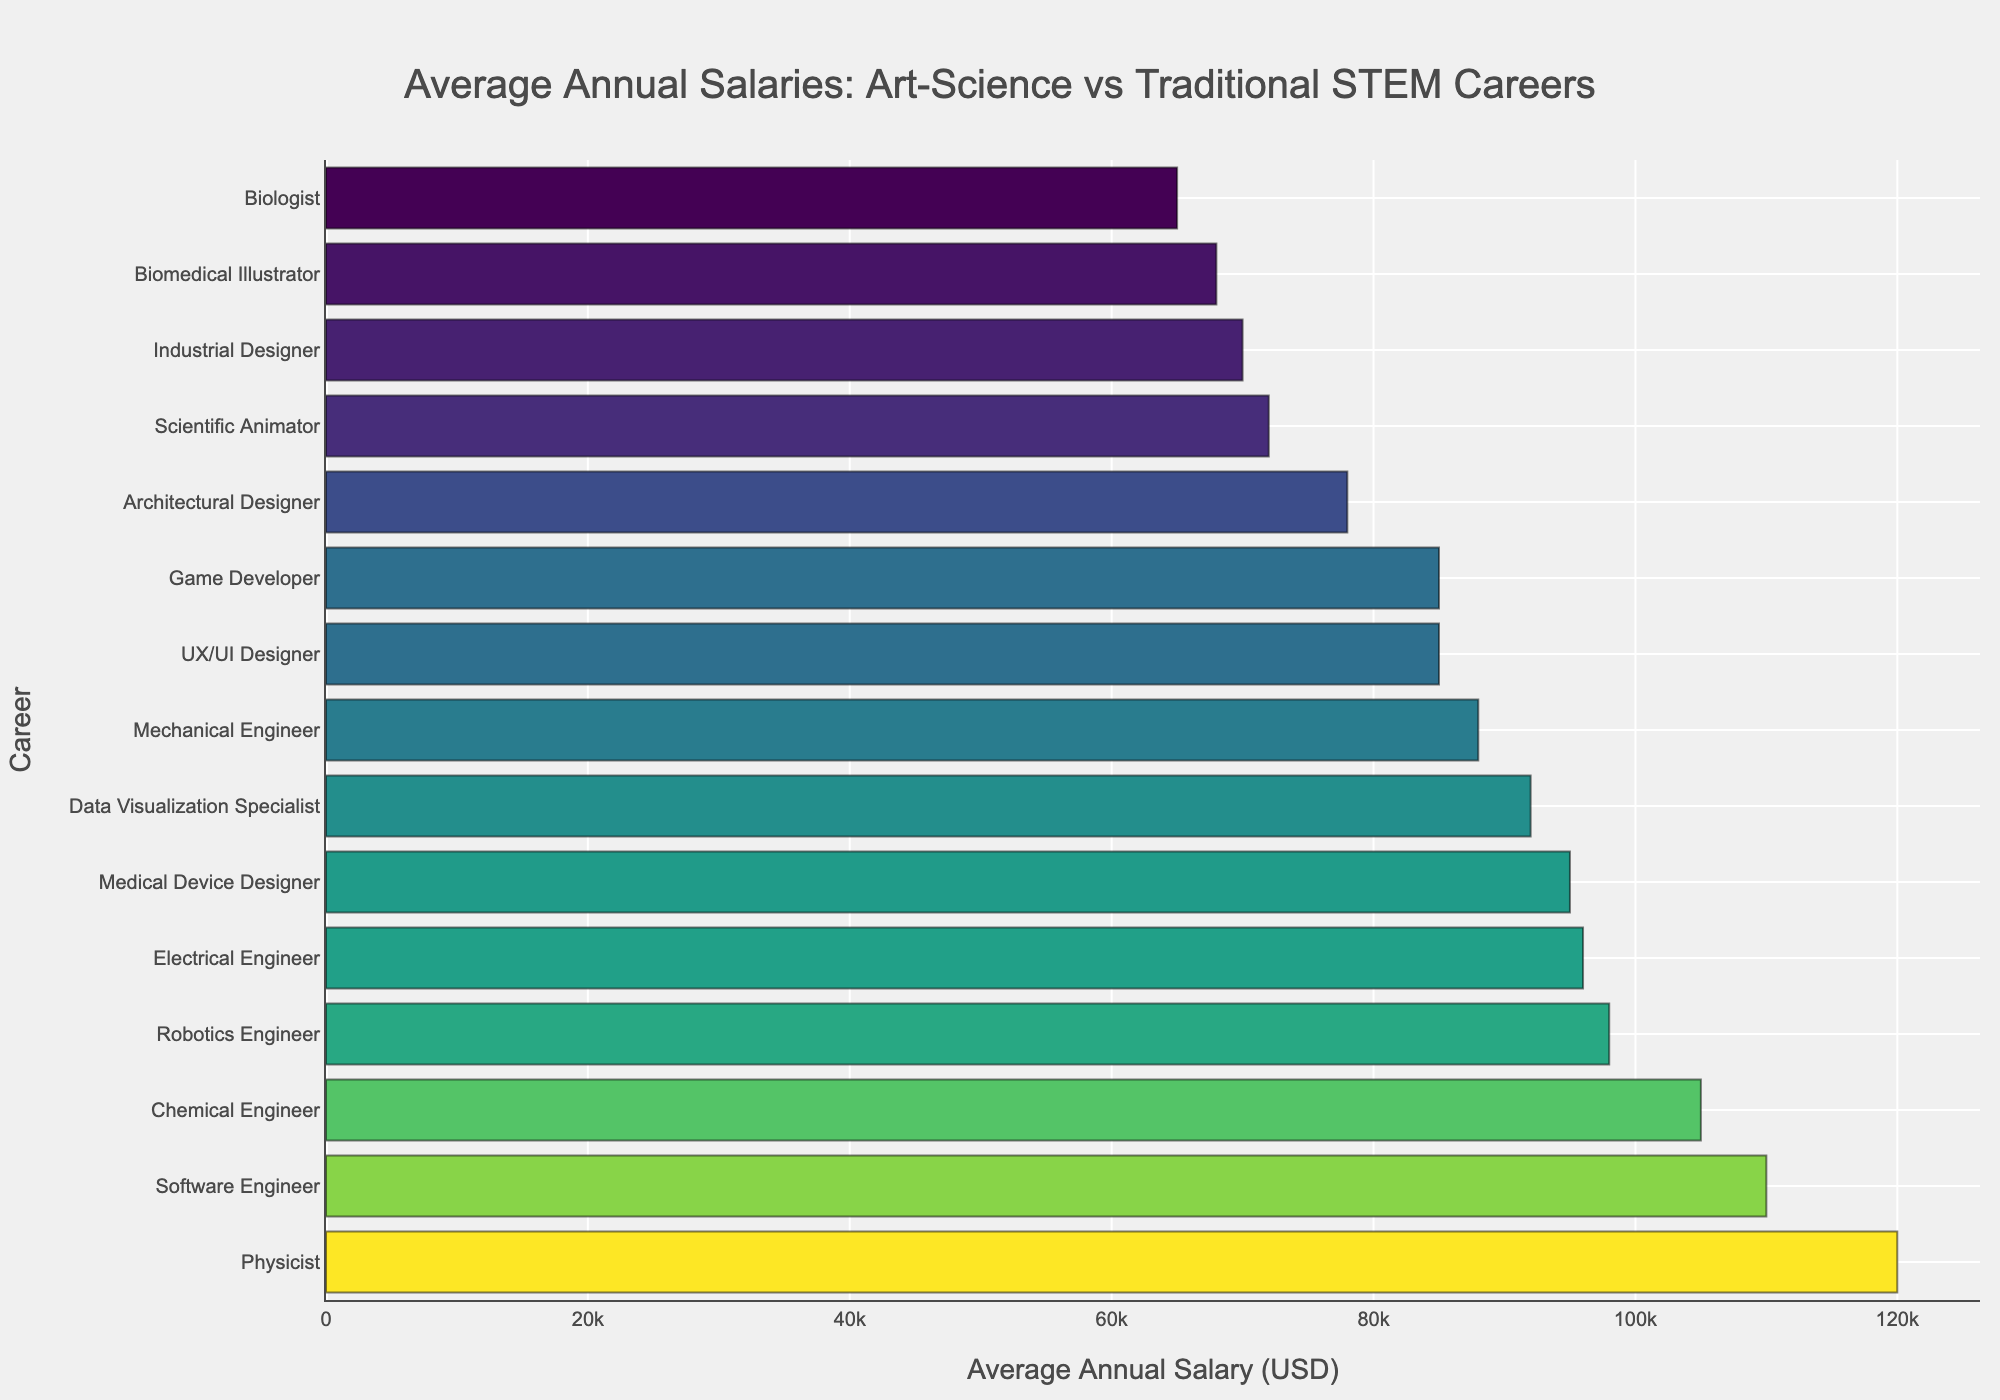Which career has the highest average annual salary? By inspecting the bar chart, the career with the longest bar represents the highest salary. The label next to the longest bar is "Physicist" with a salary of $120,000.
Answer: Physicist Which career has the lowest average annual salary? By looking at the shortest bar in the chart, the career "Biologist" has the shortest bar indicating the lowest average annual salary, which is $65,000.
Answer: Biologist Is the average annual salary of a Biomedical Illustrator higher or lower than a Data Visualization Specialist? By comparing the lengths of the bars for "Biomedical Illustrator" and "Data Visualization Specialist," we can see that the bar for "Data Visualization Specialist" is longer. Therefore, the average salary of a Data Visualization Specialist ($92,000) is higher than that of a Biomedical Illustrator ($68,000).
Answer: Lower How much more does a Software Engineer make compared to an Architect? The bar for "Software Engineer" represents an average annual salary of $110,000, while the bar for "Architectural Designer" represents $78,000. Subtracting these values, $110,000 - $78,000, we find that a Software Engineer makes $32,000 more.
Answer: $32,000 What is the combined average annual salary of a UX/UI Designer and a Game Developer? The bars for "UX/UI Designer" and "Game Developer" show salaries of $85,000 each. Adding these two amounts together, $85,000 + $85,000, gives us a combined salary of $170,000.
Answer: $170,000 Which traditional STEM career has the highest average annual salary? Among traditional STEM careers listed (Software Engineer, Mechanical Engineer, Electrical Engineer, Chemical Engineer, Biologist, Physicist), we observe that the "Physicist" has the longest bar with a salary of $120,000.
Answer: Physicist Do Industrial Designers earn more or less than Biomedical Illustrators and by how much? The bars for "Industrial Designer" and "Biomedical Illustrator" show salaries of $70,000 and $68,000, respectively. Subtracting the latter from the former, $70,000 - $68,000, we see that Industrial Designers earn $2,000 more.
Answer: $2,000 more Among art-science careers, which one has the highest average annual salary? Inspecting the bars related to art-science careers (Biomedical Illustrator, Scientific Animator, UX/UI Designer, Data Visualization Specialist, Medical Device Designer, Architectural Designer, Industrial Designer, Game Developer), the "Medical Device Designer" has the longest bar indicating the highest salary at $95,000.
Answer: Medical Device Designer What is the average salary of careers that combine art and science? The salaries for art-science careers are: $68,000 (Biomedical Illustrator), $72,000 (Scientific Animator), $85,000 (UX/UI Designer), $92,000 (Data Visualization Specialist), $95,000 (Medical Device Designer), $78,000 (Architectural Designer), $70,000 (Industrial Designer), $85,000 (Game Developer). Adding these together gives $645,000; dividing by the number of careers (8), the average salary is $645,000 / 8 = $80,625.
Answer: $80,625 Which engineering career has the lowest average annual salary? Among the engineering careers (Robotics Engineer, Software Engineer, Mechanical Engineer, Electrical Engineer, Chemical Engineer), "Mechanical Engineer" has the shortest bar which represents the lowest average annual salary at $88,000.
Answer: Mechanical Engineer 